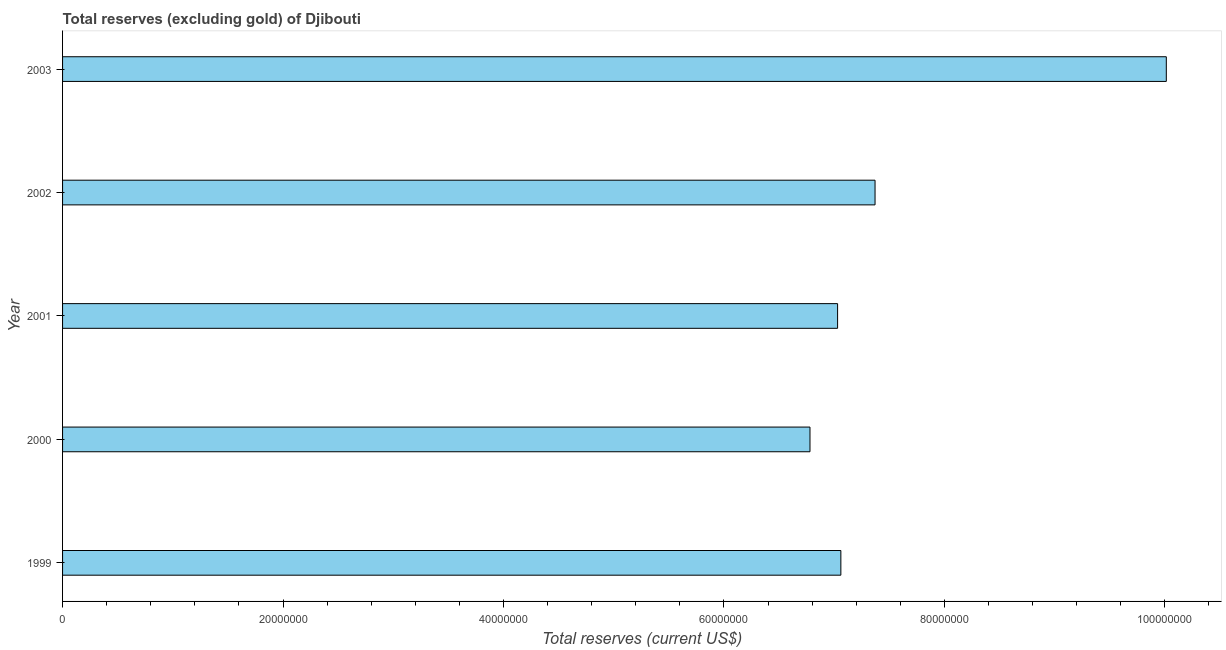What is the title of the graph?
Offer a very short reply. Total reserves (excluding gold) of Djibouti. What is the label or title of the X-axis?
Offer a very short reply. Total reserves (current US$). What is the label or title of the Y-axis?
Offer a very short reply. Year. What is the total reserves (excluding gold) in 2001?
Your answer should be very brief. 7.03e+07. Across all years, what is the maximum total reserves (excluding gold)?
Your answer should be very brief. 1.00e+08. Across all years, what is the minimum total reserves (excluding gold)?
Make the answer very short. 6.78e+07. In which year was the total reserves (excluding gold) maximum?
Keep it short and to the point. 2003. What is the sum of the total reserves (excluding gold)?
Keep it short and to the point. 3.83e+08. What is the difference between the total reserves (excluding gold) in 2000 and 2002?
Provide a short and direct response. -5.90e+06. What is the average total reserves (excluding gold) per year?
Your answer should be compact. 7.65e+07. What is the median total reserves (excluding gold)?
Keep it short and to the point. 7.06e+07. In how many years, is the total reserves (excluding gold) greater than 100000000 US$?
Your answer should be compact. 1. What is the ratio of the total reserves (excluding gold) in 2002 to that in 2003?
Offer a terse response. 0.74. Is the difference between the total reserves (excluding gold) in 1999 and 2003 greater than the difference between any two years?
Your answer should be compact. No. What is the difference between the highest and the second highest total reserves (excluding gold)?
Offer a terse response. 2.64e+07. Is the sum of the total reserves (excluding gold) in 1999 and 2002 greater than the maximum total reserves (excluding gold) across all years?
Provide a succinct answer. Yes. What is the difference between the highest and the lowest total reserves (excluding gold)?
Offer a terse response. 3.23e+07. How many bars are there?
Ensure brevity in your answer.  5. Are all the bars in the graph horizontal?
Give a very brief answer. Yes. How many years are there in the graph?
Provide a short and direct response. 5. What is the Total reserves (current US$) of 1999?
Provide a short and direct response. 7.06e+07. What is the Total reserves (current US$) of 2000?
Provide a short and direct response. 6.78e+07. What is the Total reserves (current US$) of 2001?
Provide a succinct answer. 7.03e+07. What is the Total reserves (current US$) in 2002?
Provide a short and direct response. 7.37e+07. What is the Total reserves (current US$) in 2003?
Offer a terse response. 1.00e+08. What is the difference between the Total reserves (current US$) in 1999 and 2000?
Give a very brief answer. 2.80e+06. What is the difference between the Total reserves (current US$) in 1999 and 2001?
Provide a succinct answer. 2.97e+05. What is the difference between the Total reserves (current US$) in 1999 and 2002?
Make the answer very short. -3.10e+06. What is the difference between the Total reserves (current US$) in 1999 and 2003?
Your answer should be very brief. -2.95e+07. What is the difference between the Total reserves (current US$) in 2000 and 2001?
Ensure brevity in your answer.  -2.50e+06. What is the difference between the Total reserves (current US$) in 2000 and 2002?
Offer a terse response. -5.90e+06. What is the difference between the Total reserves (current US$) in 2000 and 2003?
Your answer should be very brief. -3.23e+07. What is the difference between the Total reserves (current US$) in 2001 and 2002?
Provide a succinct answer. -3.40e+06. What is the difference between the Total reserves (current US$) in 2001 and 2003?
Provide a succinct answer. -2.98e+07. What is the difference between the Total reserves (current US$) in 2002 and 2003?
Make the answer very short. -2.64e+07. What is the ratio of the Total reserves (current US$) in 1999 to that in 2000?
Your response must be concise. 1.04. What is the ratio of the Total reserves (current US$) in 1999 to that in 2002?
Ensure brevity in your answer.  0.96. What is the ratio of the Total reserves (current US$) in 1999 to that in 2003?
Keep it short and to the point. 0.7. What is the ratio of the Total reserves (current US$) in 2000 to that in 2003?
Make the answer very short. 0.68. What is the ratio of the Total reserves (current US$) in 2001 to that in 2002?
Give a very brief answer. 0.95. What is the ratio of the Total reserves (current US$) in 2001 to that in 2003?
Provide a succinct answer. 0.7. What is the ratio of the Total reserves (current US$) in 2002 to that in 2003?
Ensure brevity in your answer.  0.74. 